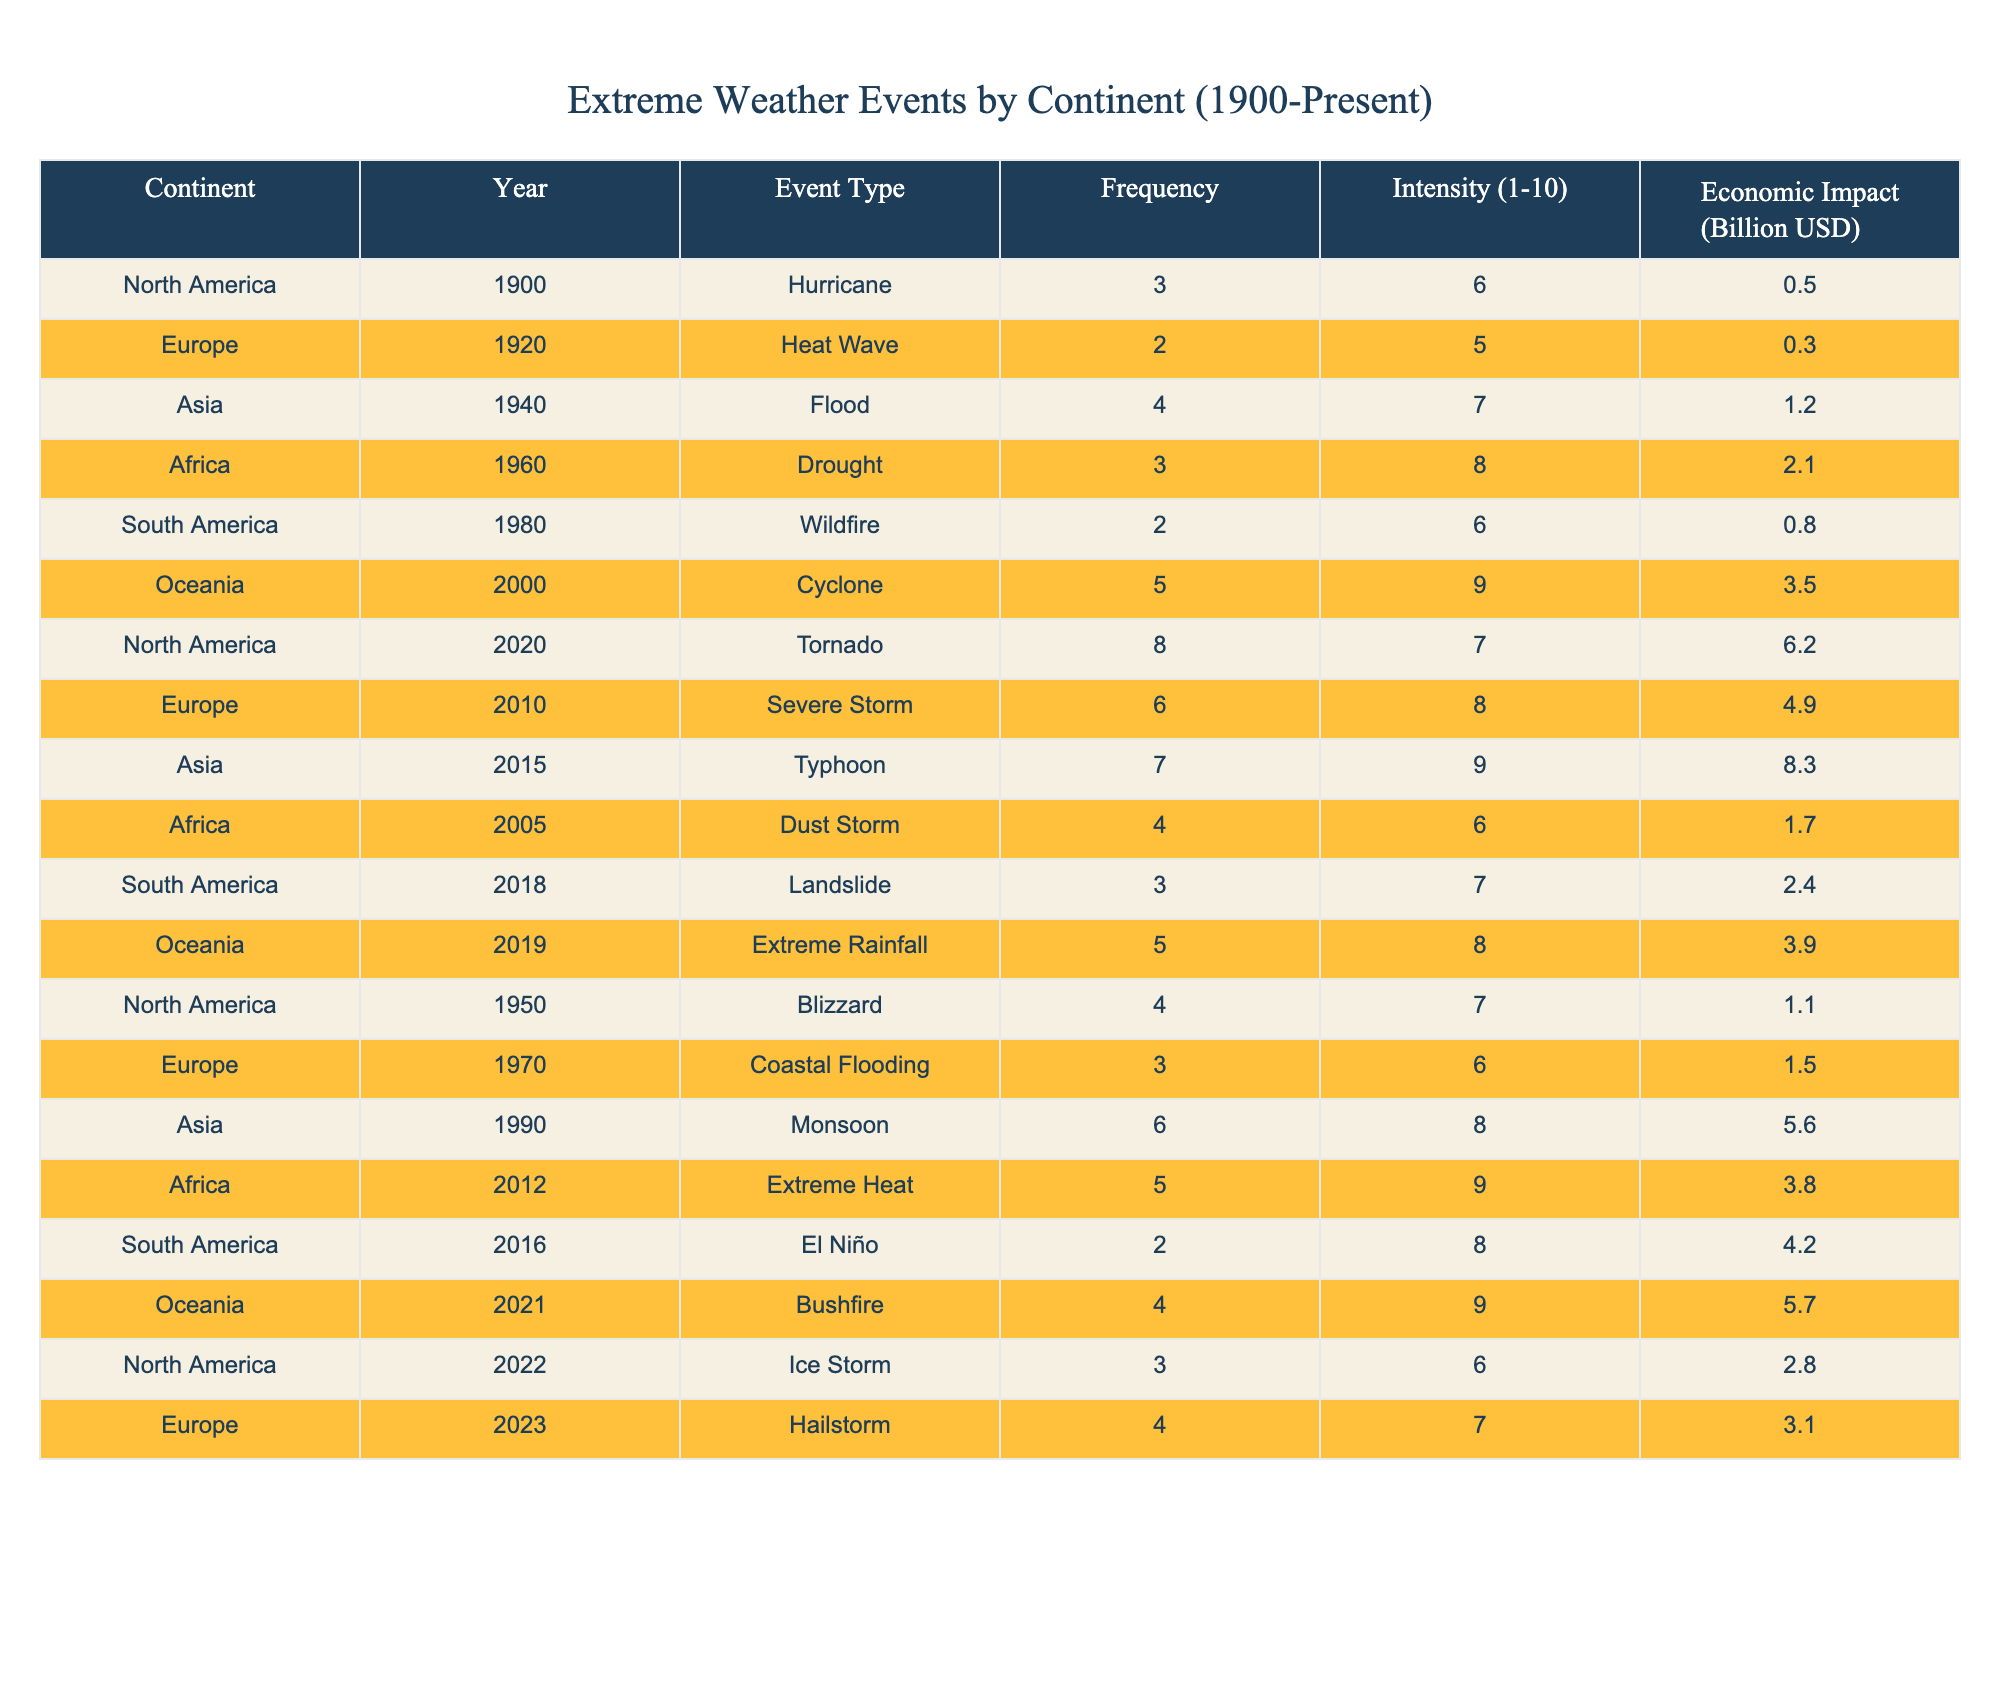What is the event type with the highest frequency in North America? In the table, the Tornado event in North America in 2020 has the highest frequency of 8.
Answer: Tornado Which continent experienced a drought event in 1960? According to the table, Africa had a drought event recorded in the year 1960.
Answer: Africa How many extreme weather events are recorded for South America from 2000 to 2023? The table shows one recorded event for South America in 2000 (Cyclone) and four events in subsequent years (Wildfire, Landslide, El Niño), totaling 5 events.
Answer: 5 What is the average intensity of extreme weather events for Asia? The intensities for Asia are 7, 9, 8. The average (7 + 9 + 8) / 3 = 8.
Answer: 8 Which continent had the lowest total economic impact from extreme weather events in the dataset? By summing the economic impacts for each continent—North America, Europe, Asia, Africa, South America, and Oceania—and comparing them, Africa has the lowest total economic impact of 7.1 billion USD.
Answer: Africa Was there a landslide event recorded in South America before 2020? The table shows that there was a Landslide event recorded in South America in 2018, which confirms that such an event occurred before 2020.
Answer: Yes Calculate the total frequency of extreme weather events recorded in Europe. The frequencies for Europe are 2 (Heat Wave) + 3 (Coastal Flooding) + 6 (Severe Storm) + 4 (Hailstorm) = 15.
Answer: 15 Is the economic impact of the Typhoon event in Asia higher than that of the Hurricane event in North America? The Typhoon in Asia in 2015 had an economic impact of 8.3 billion USD, while the Hurricane in North America in 1900 had an impact of 0.5 billion USD, so yes, the Typhoon's impact is higher.
Answer: Yes What was the average frequency of extreme weather events across all continents? Adding the frequencies from all events (3 + 2 + 4 + 3 + 2 + 5 + 8 + 6 + 7 + 4 + 6 + 5 + 2 + 4 + 3) gives a total of 60. There are 15 events, so the average frequency is 60 / 15 = 4.
Answer: 4 Which event type in Oceania had the highest intensity score? Among the events listed for Oceania, the Bushfire event in 2021 has the highest intensity score of 9.
Answer: Bushfire 